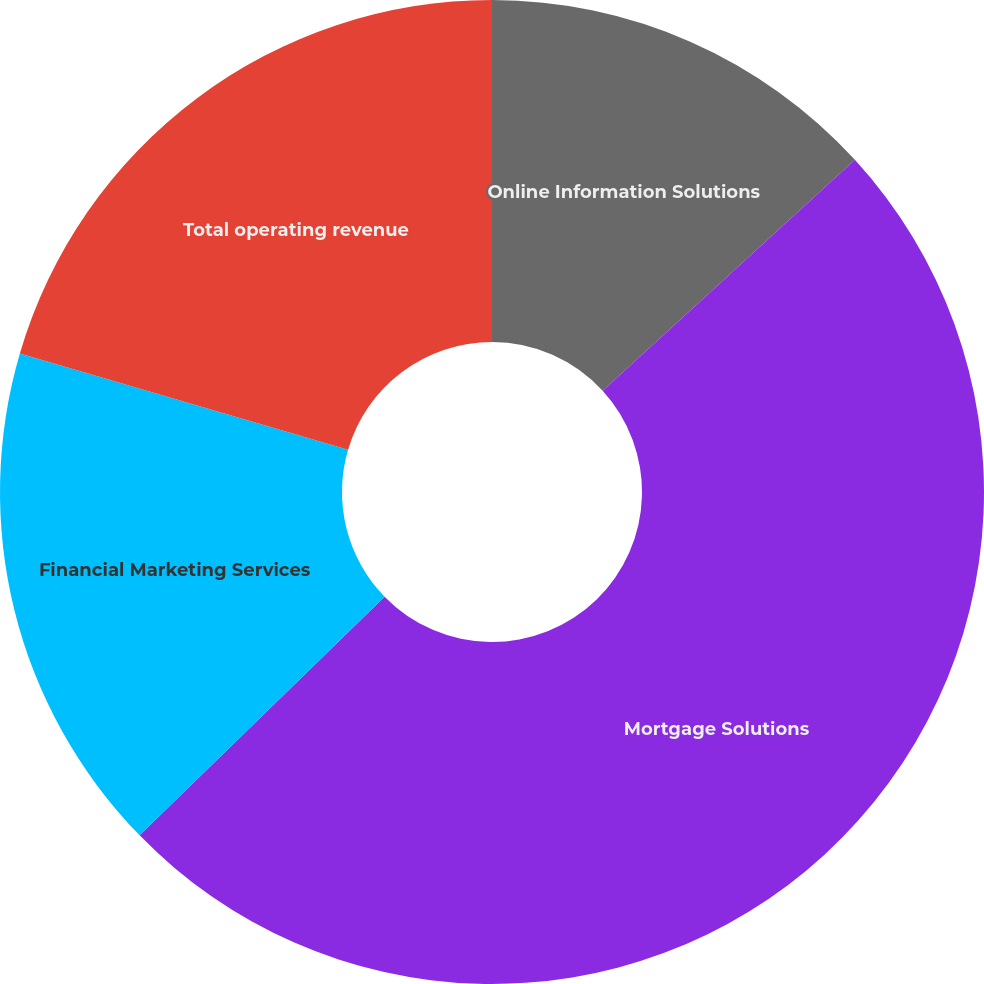<chart> <loc_0><loc_0><loc_500><loc_500><pie_chart><fcel>Online Information Solutions<fcel>Mortgage Solutions<fcel>Financial Marketing Services<fcel>Total operating revenue<nl><fcel>13.2%<fcel>49.5%<fcel>16.83%<fcel>20.46%<nl></chart> 